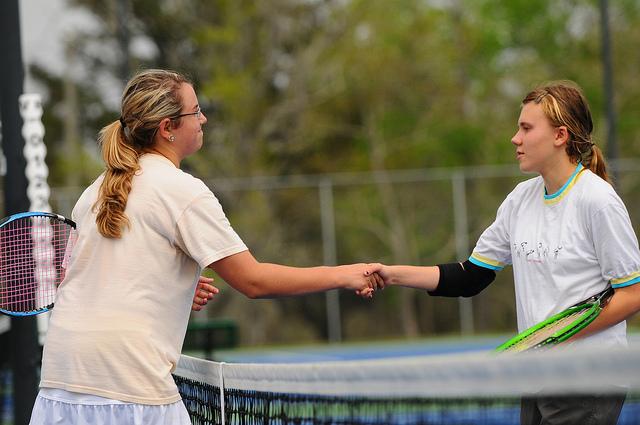Who is shaking hands?
Quick response, please. Girls. Which girl has a black elbow support?
Write a very short answer. Right one. Is she wearing a multi-colored outfit?
Keep it brief. No. What does the woman on the left have under her arm?
Short answer required. Racket. 